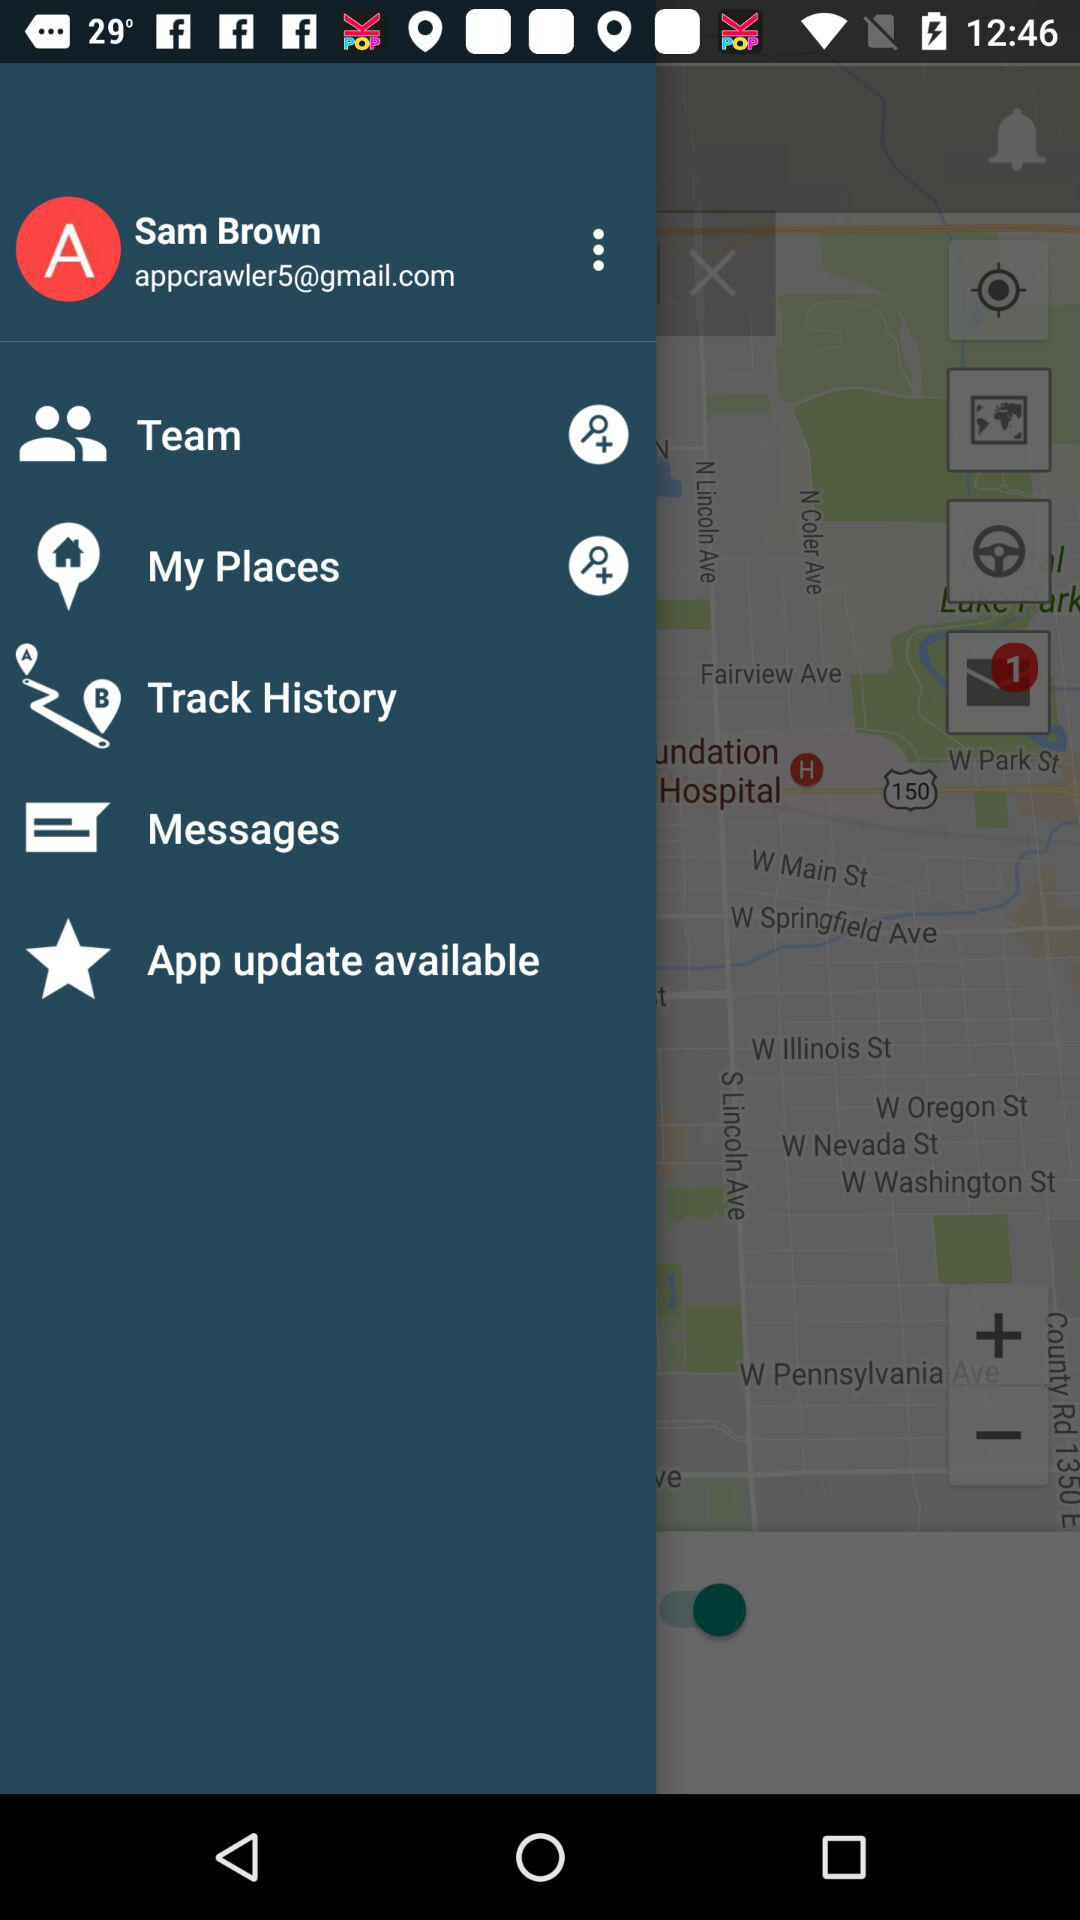How many notifications are there in "My Places"?
When the provided information is insufficient, respond with <no answer>. <no answer> 